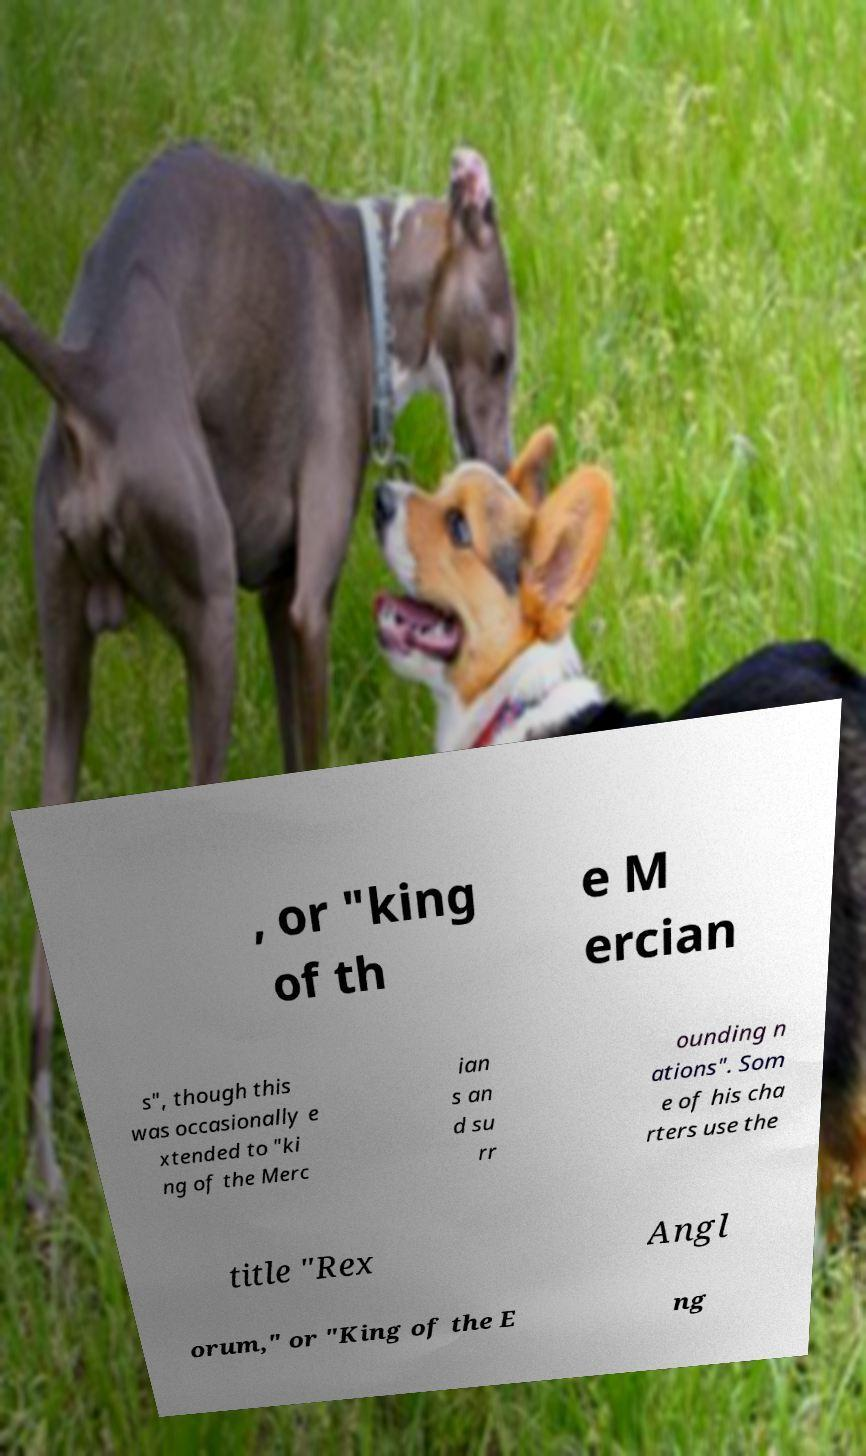Can you accurately transcribe the text from the provided image for me? , or "king of th e M ercian s", though this was occasionally e xtended to "ki ng of the Merc ian s an d su rr ounding n ations". Som e of his cha rters use the title "Rex Angl orum," or "King of the E ng 